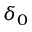<formula> <loc_0><loc_0><loc_500><loc_500>\delta _ { 0 }</formula> 